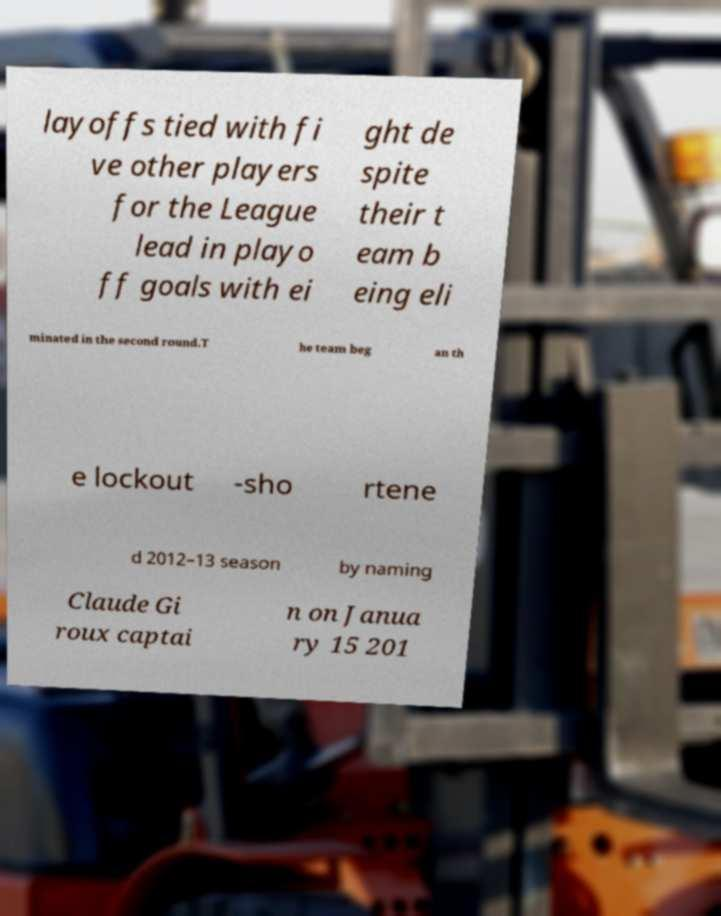Please read and relay the text visible in this image. What does it say? layoffs tied with fi ve other players for the League lead in playo ff goals with ei ght de spite their t eam b eing eli minated in the second round.T he team beg an th e lockout -sho rtene d 2012–13 season by naming Claude Gi roux captai n on Janua ry 15 201 